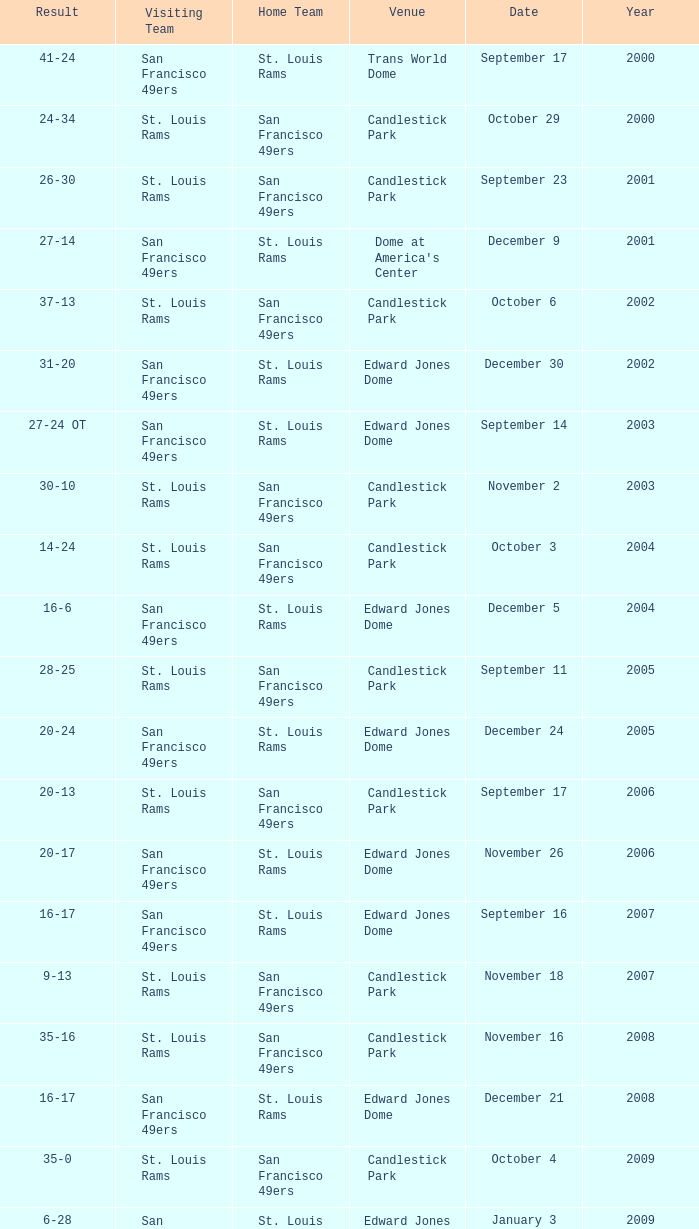What was the Venue on November 26? Edward Jones Dome. 